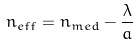Convert formula to latex. <formula><loc_0><loc_0><loc_500><loc_500>n _ { e f f } = n _ { m e d } - \frac { \lambda } { a }</formula> 